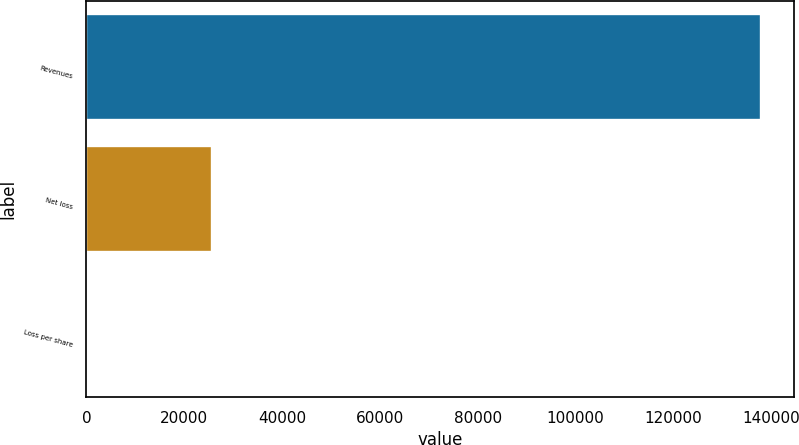Convert chart to OTSL. <chart><loc_0><loc_0><loc_500><loc_500><bar_chart><fcel>Revenues<fcel>Net loss<fcel>Loss per share<nl><fcel>137808<fcel>25694<fcel>1.68<nl></chart> 